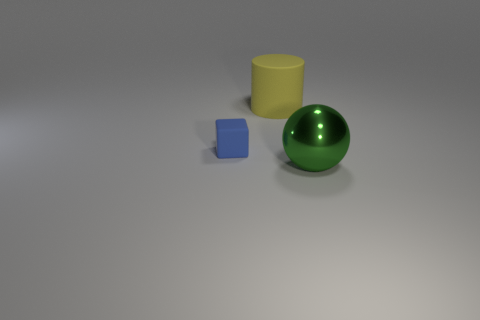Add 3 yellow rubber objects. How many objects exist? 6 Subtract all blocks. How many objects are left? 2 Subtract 0 gray spheres. How many objects are left? 3 Subtract all big cyan cubes. Subtract all small cubes. How many objects are left? 2 Add 1 large green balls. How many large green balls are left? 2 Add 2 green spheres. How many green spheres exist? 3 